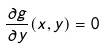<formula> <loc_0><loc_0><loc_500><loc_500>\frac { \partial g } { \partial y } ( x , y ) = 0</formula> 